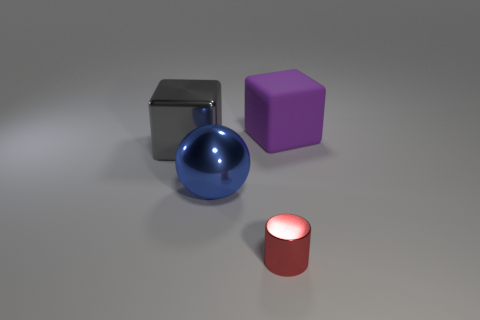Is the shiny ball the same color as the matte cube?
Give a very brief answer. No. The large block that is left of the large block that is to the right of the large gray metallic cube is made of what material?
Your answer should be very brief. Metal. There is another large thing that is the same shape as the large gray metal thing; what material is it?
Your response must be concise. Rubber. There is a cube on the left side of the metallic thing in front of the blue metal thing; are there any red shiny cylinders that are behind it?
Your answer should be very brief. No. How many other things are the same color as the matte object?
Your response must be concise. 0. How many big things are both behind the large metal ball and left of the small shiny object?
Offer a terse response. 1. What is the shape of the purple thing?
Provide a succinct answer. Cube. How many other things are there of the same material as the big purple cube?
Ensure brevity in your answer.  0. What is the color of the large block in front of the big cube behind the metallic thing to the left of the big metal ball?
Your response must be concise. Gray. There is a gray cube that is the same size as the blue shiny sphere; what material is it?
Ensure brevity in your answer.  Metal. 